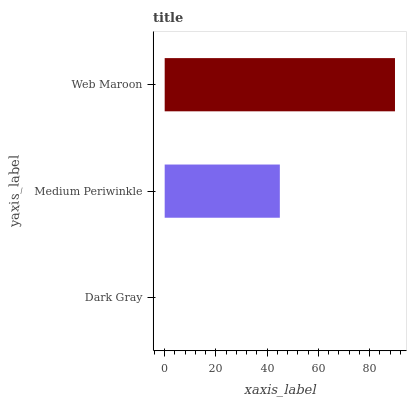Is Dark Gray the minimum?
Answer yes or no. Yes. Is Web Maroon the maximum?
Answer yes or no. Yes. Is Medium Periwinkle the minimum?
Answer yes or no. No. Is Medium Periwinkle the maximum?
Answer yes or no. No. Is Medium Periwinkle greater than Dark Gray?
Answer yes or no. Yes. Is Dark Gray less than Medium Periwinkle?
Answer yes or no. Yes. Is Dark Gray greater than Medium Periwinkle?
Answer yes or no. No. Is Medium Periwinkle less than Dark Gray?
Answer yes or no. No. Is Medium Periwinkle the high median?
Answer yes or no. Yes. Is Medium Periwinkle the low median?
Answer yes or no. Yes. Is Dark Gray the high median?
Answer yes or no. No. Is Dark Gray the low median?
Answer yes or no. No. 